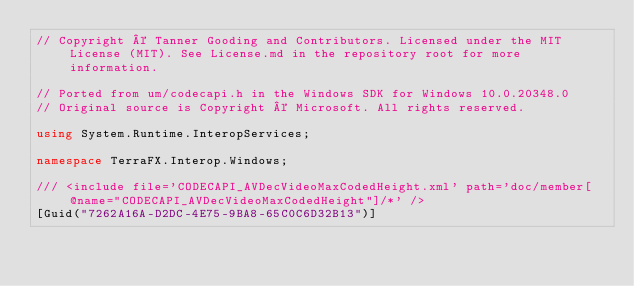Convert code to text. <code><loc_0><loc_0><loc_500><loc_500><_C#_>// Copyright © Tanner Gooding and Contributors. Licensed under the MIT License (MIT). See License.md in the repository root for more information.

// Ported from um/codecapi.h in the Windows SDK for Windows 10.0.20348.0
// Original source is Copyright © Microsoft. All rights reserved.

using System.Runtime.InteropServices;

namespace TerraFX.Interop.Windows;

/// <include file='CODECAPI_AVDecVideoMaxCodedHeight.xml' path='doc/member[@name="CODECAPI_AVDecVideoMaxCodedHeight"]/*' />
[Guid("7262A16A-D2DC-4E75-9BA8-65C0C6D32B13")]</code> 